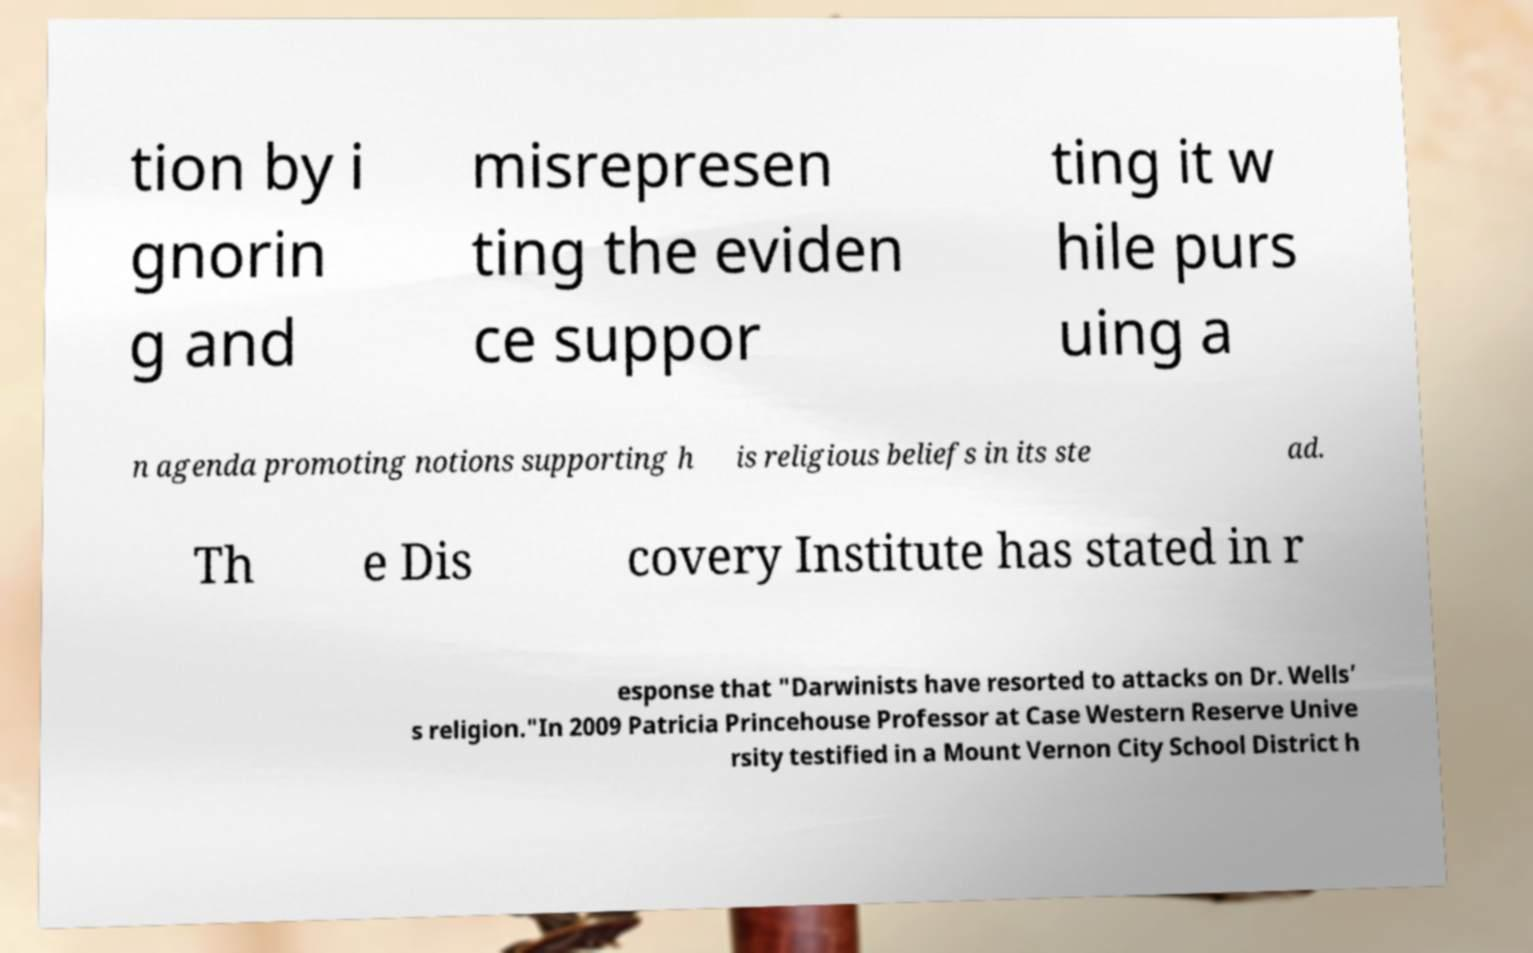Can you accurately transcribe the text from the provided image for me? tion by i gnorin g and misrepresen ting the eviden ce suppor ting it w hile purs uing a n agenda promoting notions supporting h is religious beliefs in its ste ad. Th e Dis covery Institute has stated in r esponse that "Darwinists have resorted to attacks on Dr. Wells’ s religion."In 2009 Patricia Princehouse Professor at Case Western Reserve Unive rsity testified in a Mount Vernon City School District h 